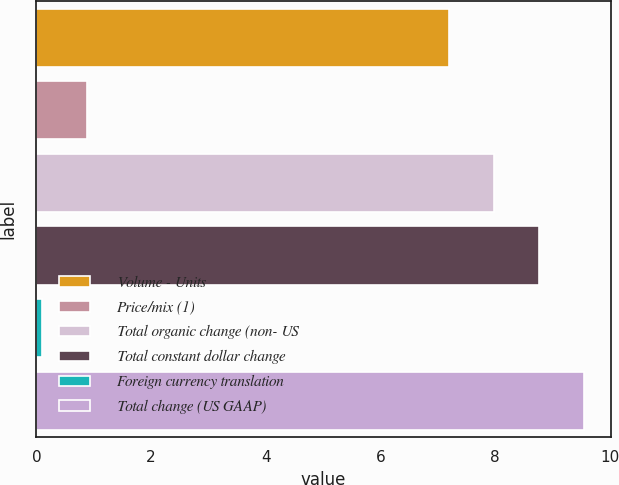<chart> <loc_0><loc_0><loc_500><loc_500><bar_chart><fcel>Volume - Units<fcel>Price/mix (1)<fcel>Total organic change (non- US<fcel>Total constant dollar change<fcel>Foreign currency translation<fcel>Total change (US GAAP)<nl><fcel>7.2<fcel>0.88<fcel>7.98<fcel>8.76<fcel>0.1<fcel>9.54<nl></chart> 